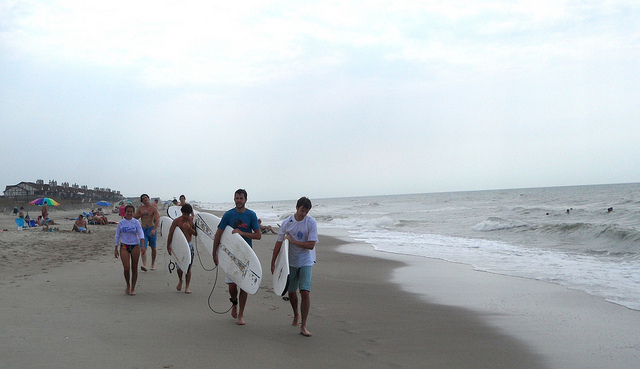Describe the attire of the people in the image. The individuals appear dressed for beach activities; some wear swimsuits while others are in casual beachwear like shorts and t-shirts. The attire suggests a relaxed, recreational environment where water activities are anticipated. Do their clothes tell you anything about the weather or the water temperature? While swimsuits suggest a warmer temperature suitable for swimming or surfing, the presence of t-shirts and shorts could indicate that it is not excessively hot, and the overcast sky may have brought cooler air. The attire suggests mild to warm weather but not a hot summer day. 